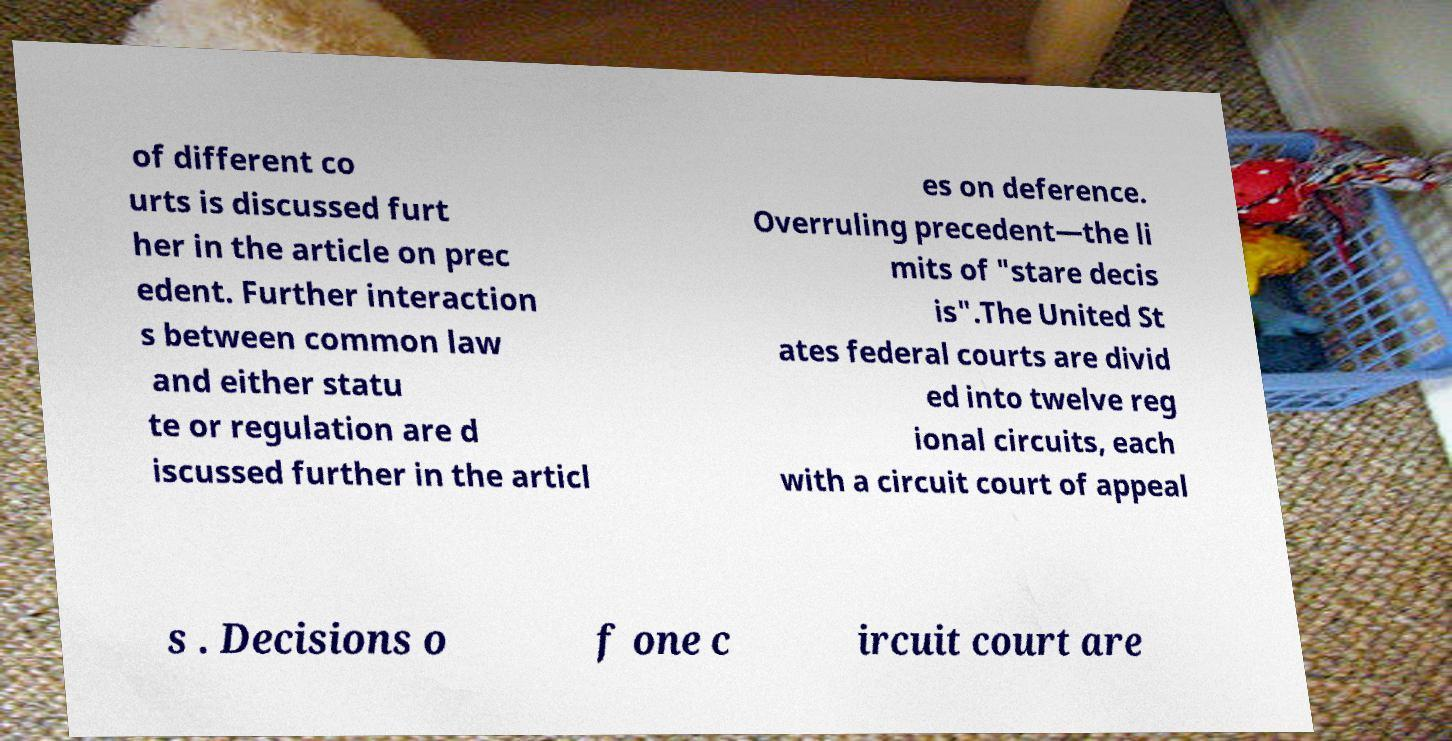Can you read and provide the text displayed in the image?This photo seems to have some interesting text. Can you extract and type it out for me? of different co urts is discussed furt her in the article on prec edent. Further interaction s between common law and either statu te or regulation are d iscussed further in the articl es on deference. Overruling precedent—the li mits of "stare decis is".The United St ates federal courts are divid ed into twelve reg ional circuits, each with a circuit court of appeal s . Decisions o f one c ircuit court are 